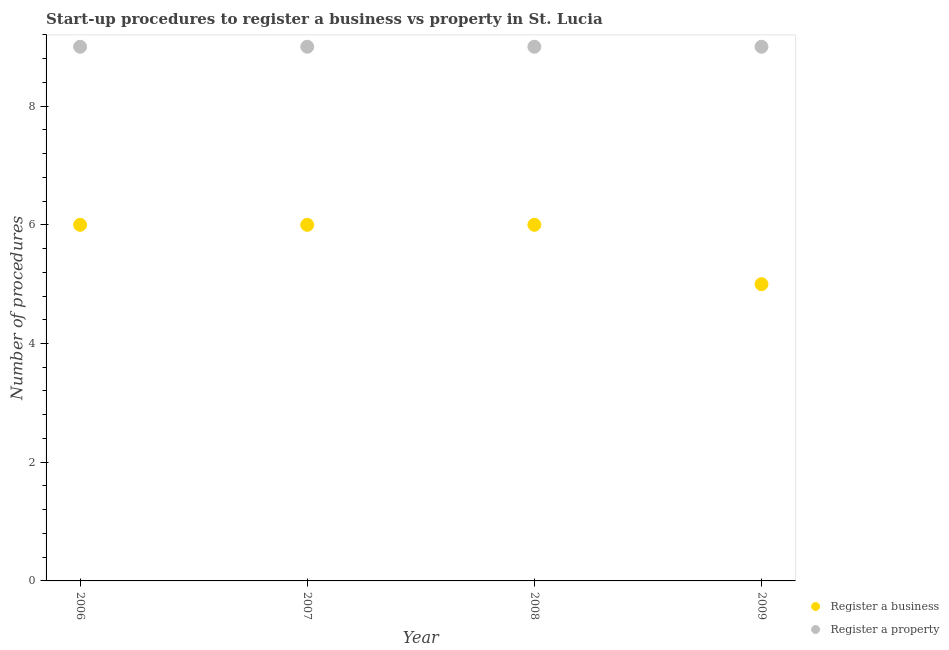What is the number of procedures to register a business in 2009?
Give a very brief answer. 5. Across all years, what is the maximum number of procedures to register a business?
Ensure brevity in your answer.  6. Across all years, what is the minimum number of procedures to register a property?
Offer a terse response. 9. What is the total number of procedures to register a business in the graph?
Ensure brevity in your answer.  23. What is the difference between the number of procedures to register a property in 2007 and the number of procedures to register a business in 2008?
Offer a very short reply. 3. What is the average number of procedures to register a business per year?
Offer a very short reply. 5.75. In the year 2009, what is the difference between the number of procedures to register a property and number of procedures to register a business?
Give a very brief answer. 4. In how many years, is the number of procedures to register a business greater than 4?
Offer a terse response. 4. Is the number of procedures to register a business in 2008 less than that in 2009?
Provide a short and direct response. No. Is the difference between the number of procedures to register a property in 2007 and 2009 greater than the difference between the number of procedures to register a business in 2007 and 2009?
Offer a terse response. No. What is the difference between the highest and the second highest number of procedures to register a property?
Your answer should be compact. 0. What is the difference between the highest and the lowest number of procedures to register a property?
Make the answer very short. 0. Is the sum of the number of procedures to register a property in 2006 and 2007 greater than the maximum number of procedures to register a business across all years?
Offer a terse response. Yes. Is the number of procedures to register a business strictly greater than the number of procedures to register a property over the years?
Provide a short and direct response. No. Is the number of procedures to register a property strictly less than the number of procedures to register a business over the years?
Offer a terse response. No. How many dotlines are there?
Make the answer very short. 2. How many years are there in the graph?
Provide a short and direct response. 4. What is the difference between two consecutive major ticks on the Y-axis?
Keep it short and to the point. 2. Where does the legend appear in the graph?
Ensure brevity in your answer.  Bottom right. What is the title of the graph?
Offer a terse response. Start-up procedures to register a business vs property in St. Lucia. Does "From human activities" appear as one of the legend labels in the graph?
Offer a very short reply. No. What is the label or title of the Y-axis?
Offer a very short reply. Number of procedures. What is the Number of procedures in Register a business in 2006?
Make the answer very short. 6. What is the Number of procedures in Register a property in 2006?
Ensure brevity in your answer.  9. What is the Number of procedures of Register a property in 2008?
Offer a very short reply. 9. What is the Number of procedures in Register a property in 2009?
Keep it short and to the point. 9. Across all years, what is the minimum Number of procedures of Register a business?
Make the answer very short. 5. Across all years, what is the minimum Number of procedures in Register a property?
Ensure brevity in your answer.  9. What is the total Number of procedures in Register a property in the graph?
Your answer should be very brief. 36. What is the difference between the Number of procedures of Register a business in 2006 and that in 2007?
Your response must be concise. 0. What is the difference between the Number of procedures of Register a business in 2006 and that in 2008?
Provide a short and direct response. 0. What is the difference between the Number of procedures of Register a property in 2006 and that in 2008?
Offer a terse response. 0. What is the difference between the Number of procedures in Register a property in 2006 and that in 2009?
Your response must be concise. 0. What is the difference between the Number of procedures of Register a business in 2007 and that in 2008?
Keep it short and to the point. 0. What is the difference between the Number of procedures of Register a property in 2007 and that in 2008?
Ensure brevity in your answer.  0. What is the difference between the Number of procedures in Register a business in 2007 and that in 2009?
Make the answer very short. 1. What is the difference between the Number of procedures in Register a property in 2007 and that in 2009?
Provide a succinct answer. 0. What is the difference between the Number of procedures of Register a business in 2008 and that in 2009?
Ensure brevity in your answer.  1. What is the difference between the Number of procedures of Register a business in 2006 and the Number of procedures of Register a property in 2008?
Your answer should be compact. -3. What is the difference between the Number of procedures of Register a business in 2007 and the Number of procedures of Register a property in 2008?
Make the answer very short. -3. What is the average Number of procedures in Register a business per year?
Your answer should be very brief. 5.75. What is the average Number of procedures of Register a property per year?
Make the answer very short. 9. In the year 2006, what is the difference between the Number of procedures of Register a business and Number of procedures of Register a property?
Give a very brief answer. -3. In the year 2008, what is the difference between the Number of procedures in Register a business and Number of procedures in Register a property?
Offer a very short reply. -3. In the year 2009, what is the difference between the Number of procedures in Register a business and Number of procedures in Register a property?
Your answer should be very brief. -4. What is the ratio of the Number of procedures of Register a business in 2006 to that in 2008?
Offer a very short reply. 1. What is the ratio of the Number of procedures in Register a business in 2006 to that in 2009?
Your answer should be compact. 1.2. What is the ratio of the Number of procedures in Register a property in 2007 to that in 2008?
Keep it short and to the point. 1. What is the ratio of the Number of procedures of Register a business in 2008 to that in 2009?
Give a very brief answer. 1.2. What is the difference between the highest and the second highest Number of procedures in Register a property?
Provide a succinct answer. 0. What is the difference between the highest and the lowest Number of procedures of Register a business?
Give a very brief answer. 1. 